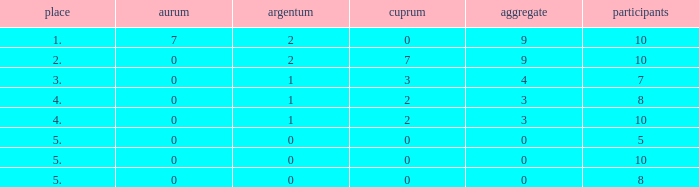What's the total Rank that has a Gold that's smaller than 0? None. 